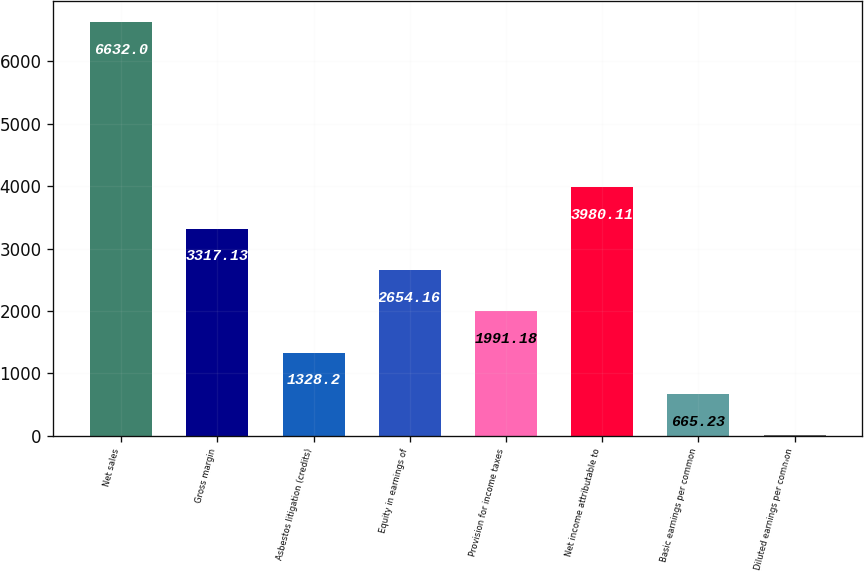Convert chart to OTSL. <chart><loc_0><loc_0><loc_500><loc_500><bar_chart><fcel>Net sales<fcel>Gross margin<fcel>Asbestos litigation (credits)<fcel>Equity in earnings of<fcel>Provision for income taxes<fcel>Net income attributable to<fcel>Basic earnings per common<fcel>Diluted earnings per common<nl><fcel>6632<fcel>3317.13<fcel>1328.2<fcel>2654.16<fcel>1991.18<fcel>3980.11<fcel>665.23<fcel>2.25<nl></chart> 